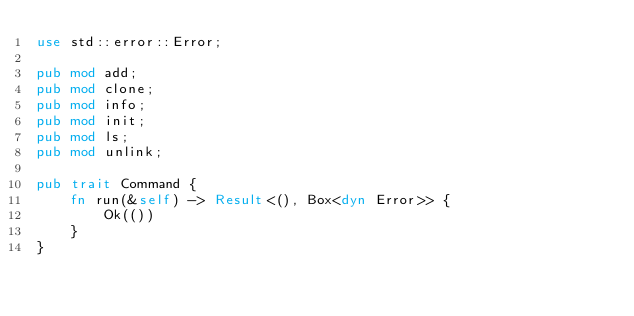Convert code to text. <code><loc_0><loc_0><loc_500><loc_500><_Rust_>use std::error::Error;

pub mod add;
pub mod clone;
pub mod info;
pub mod init;
pub mod ls;
pub mod unlink;

pub trait Command {
    fn run(&self) -> Result<(), Box<dyn Error>> {
        Ok(())
    }
}
</code> 